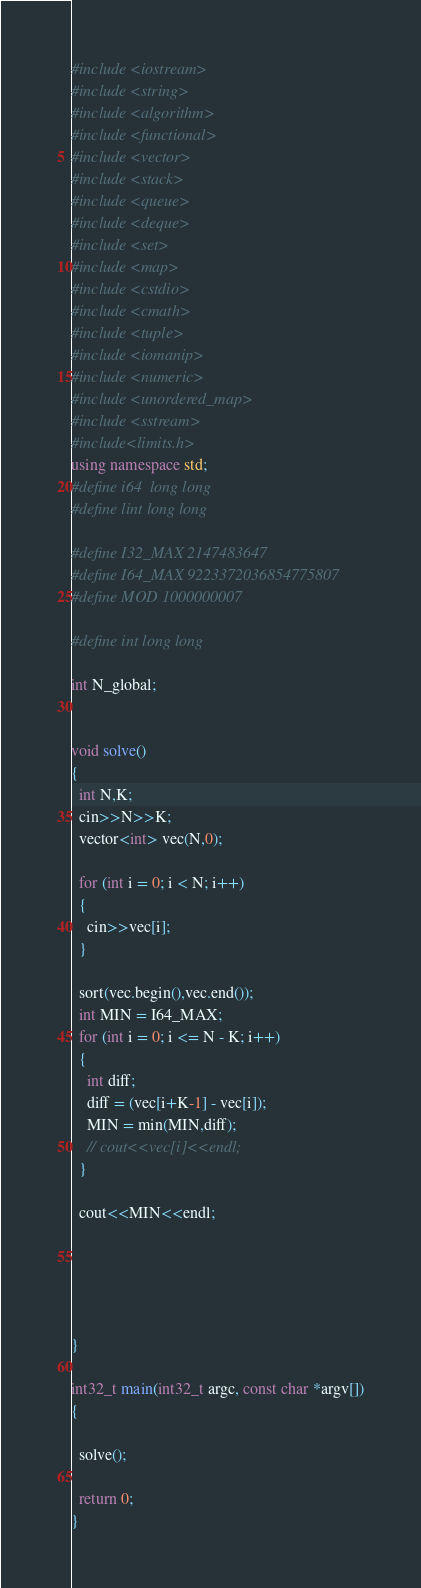Convert code to text. <code><loc_0><loc_0><loc_500><loc_500><_C++_>#include <iostream>
#include <string>
#include <algorithm>
#include <functional>
#include <vector>
#include <stack>
#include <queue>
#include <deque>
#include <set>
#include <map>
#include <cstdio>
#include <cmath>
#include <tuple>
#include <iomanip>
#include <numeric>
#include <unordered_map>
#include <sstream>   
#include<limits.h>
using namespace std;
#define i64  long long
#define lint long long
 
#define I32_MAX 2147483647
#define I64_MAX 9223372036854775807
#define MOD 1000000007

#define int long long

int N_global;


void solve()
{
  int N,K;
  cin>>N>>K;
  vector<int> vec(N,0);
  
  for (int i = 0; i < N; i++)
  {
    cin>>vec[i];
  }

  sort(vec.begin(),vec.end());
  int MIN = I64_MAX;
  for (int i = 0; i <= N - K; i++)
  {
    int diff;
    diff = (vec[i+K-1] - vec[i]);
    MIN = min(MIN,diff);
    // cout<<vec[i]<<endl;
  }

  cout<<MIN<<endl;
  

  
  
  
}
 
int32_t main(int32_t argc, const char *argv[])
{
 
  solve();
 
  return 0;
}</code> 